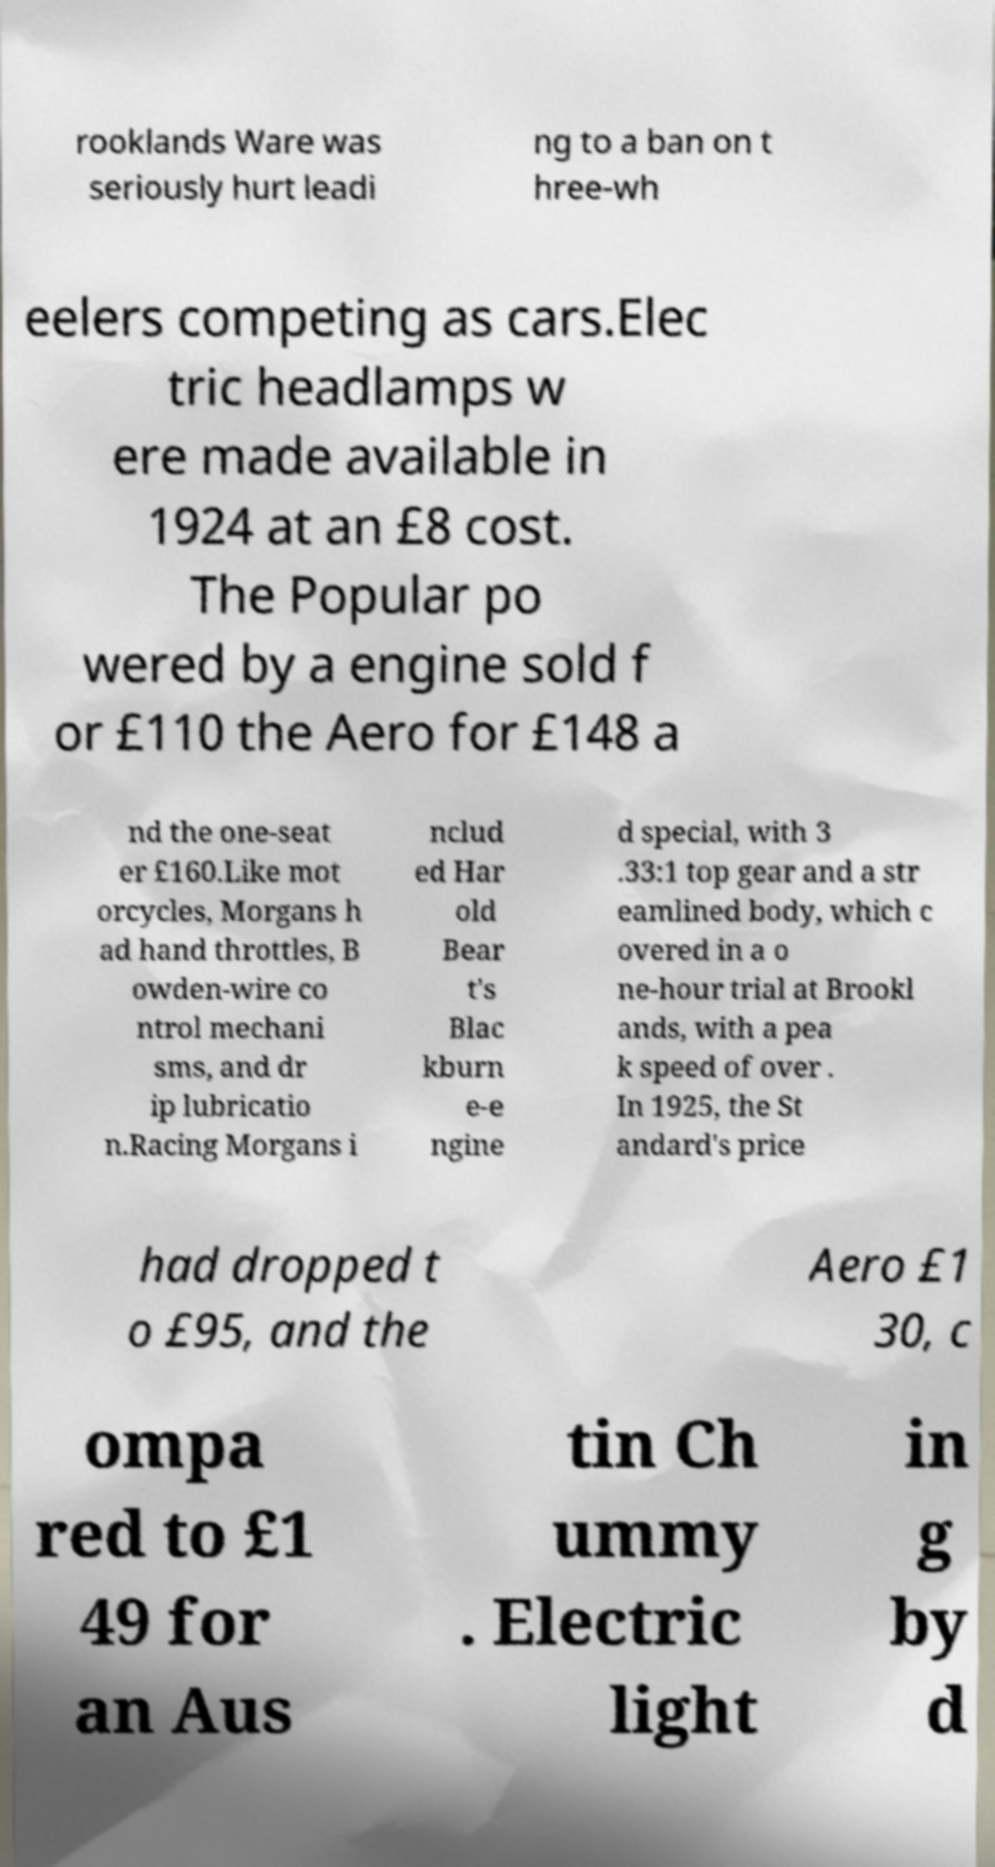Can you read and provide the text displayed in the image?This photo seems to have some interesting text. Can you extract and type it out for me? rooklands Ware was seriously hurt leadi ng to a ban on t hree-wh eelers competing as cars.Elec tric headlamps w ere made available in 1924 at an £8 cost. The Popular po wered by a engine sold f or £110 the Aero for £148 a nd the one-seat er £160.Like mot orcycles, Morgans h ad hand throttles, B owden-wire co ntrol mechani sms, and dr ip lubricatio n.Racing Morgans i nclud ed Har old Bear t's Blac kburn e-e ngine d special, with 3 .33:1 top gear and a str eamlined body, which c overed in a o ne-hour trial at Brookl ands, with a pea k speed of over . In 1925, the St andard's price had dropped t o £95, and the Aero £1 30, c ompa red to £1 49 for an Aus tin Ch ummy . Electric light in g by d 